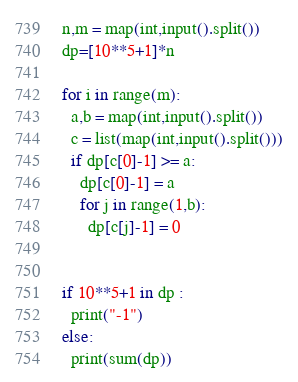Convert code to text. <code><loc_0><loc_0><loc_500><loc_500><_Python_>n,m = map(int,input().split())
dp=[10**5+1]*n

for i in range(m):
  a,b = map(int,input().split())
  c = list(map(int,input().split()))
  if dp[c[0]-1] >= a:
    dp[c[0]-1] = a
    for j in range(1,b):
      dp[c[j]-1] = 0
  
  
if 10**5+1 in dp :
  print("-1")
else:
  print(sum(dp))</code> 